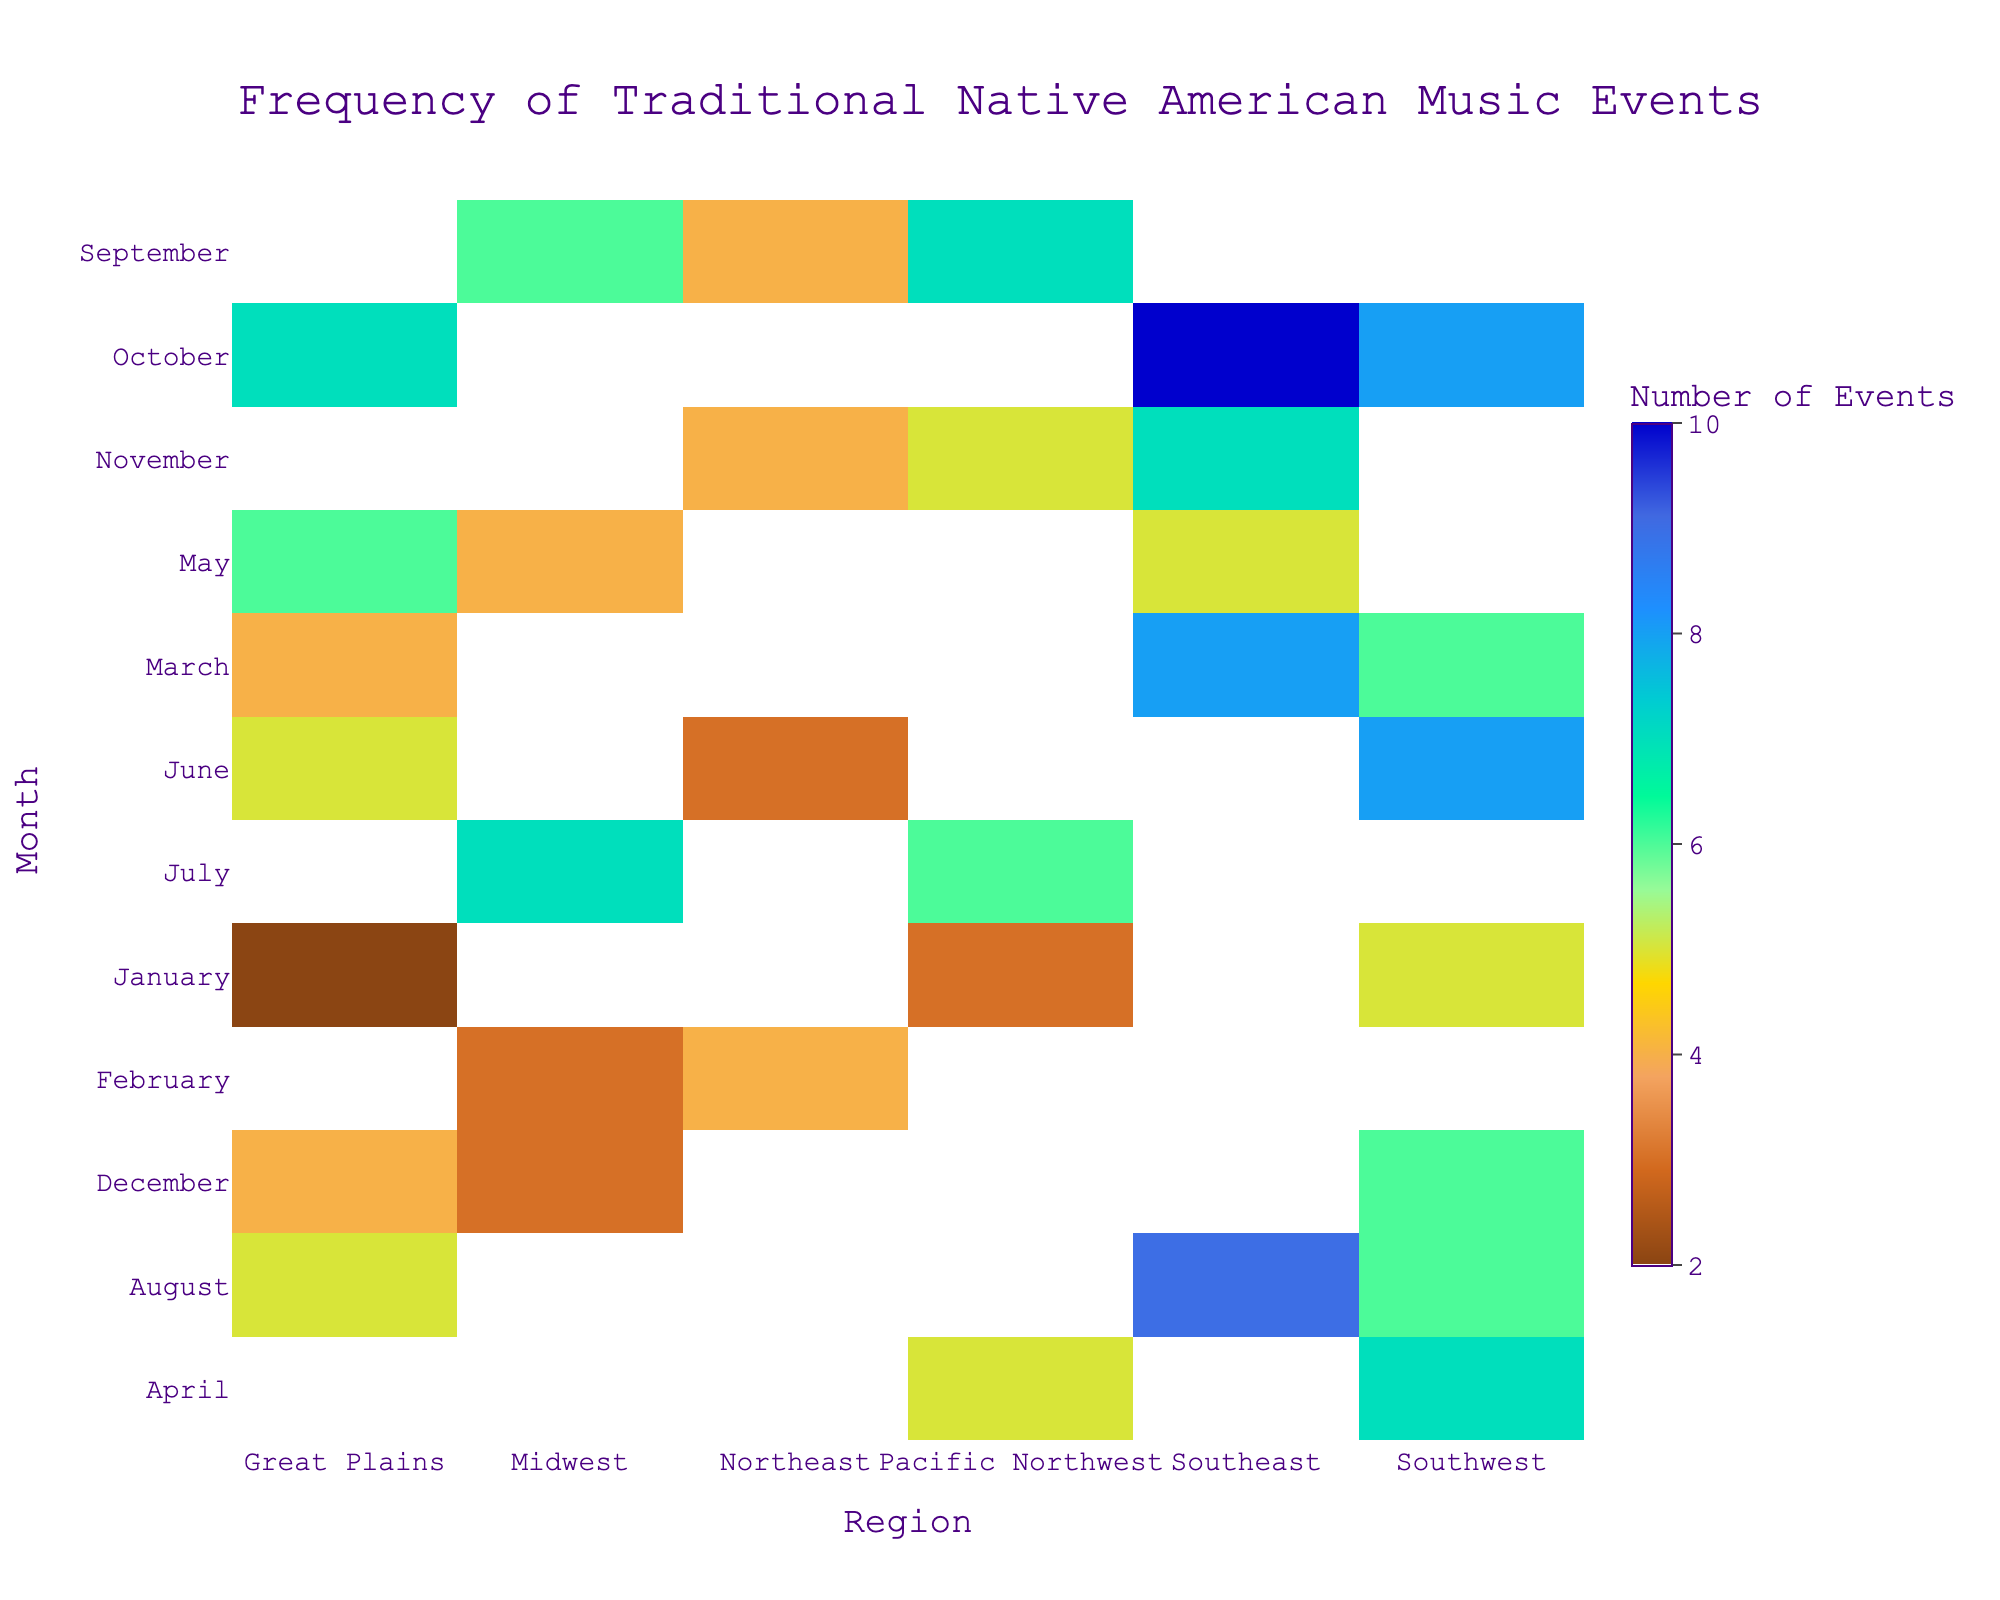Which month has the highest number of events in the Southeast region? Locate the "Southeast" column and find the maximum value. The month corresponding to this maximum value is the answer.
Answer: October Which region holds the most events in March? Look at the "March" row and identify the region that has the highest frequency value.
Answer: Southeast Which month has the lowest number of events in the Great Plains? Locate the "Great Plains" column and find the minimum value. The month corresponding to this minimum value is the answer.
Answer: January In which month does the Midwest region have the highest number of events? Locate the "Midwest" column and identify the maximum value to find the corresponding month.
Answer: July How many total events occurred in the Northeast region throughout the year? Sum all the values in the "Northeast" column: 4 + 3 + 4 = 11
Answer: 11 Which month and region combination has the highest number of events? Identify the highest value in the entire heatmap and note the corresponding month and region.
Answer: October, Southeast Are there any months where the event frequency is the same across multiple regions? Check each row for any repeated numbers.
Answer: No Compare the number of events in the Southwest region between March and June. Which month has more events? Locate the values for "Southwest" in March and June. Compare the numbers to see which is higher: March (6) vs June (8).
Answer: June How does the frequency of events in the Pacific Northwest vary between April and July? Observe and compare the values in "Pacific Northwest" between April (5) and July (6).
Answer: The number of events increases by 1 What is the average number of events per month in the Southwest region? Sum all the values in the "Southwest" column and divide by the number of months (12): (5 + 6 + 8 + 6 + 4 + 7 + 8) / 12 = 7.
Answer: 7 